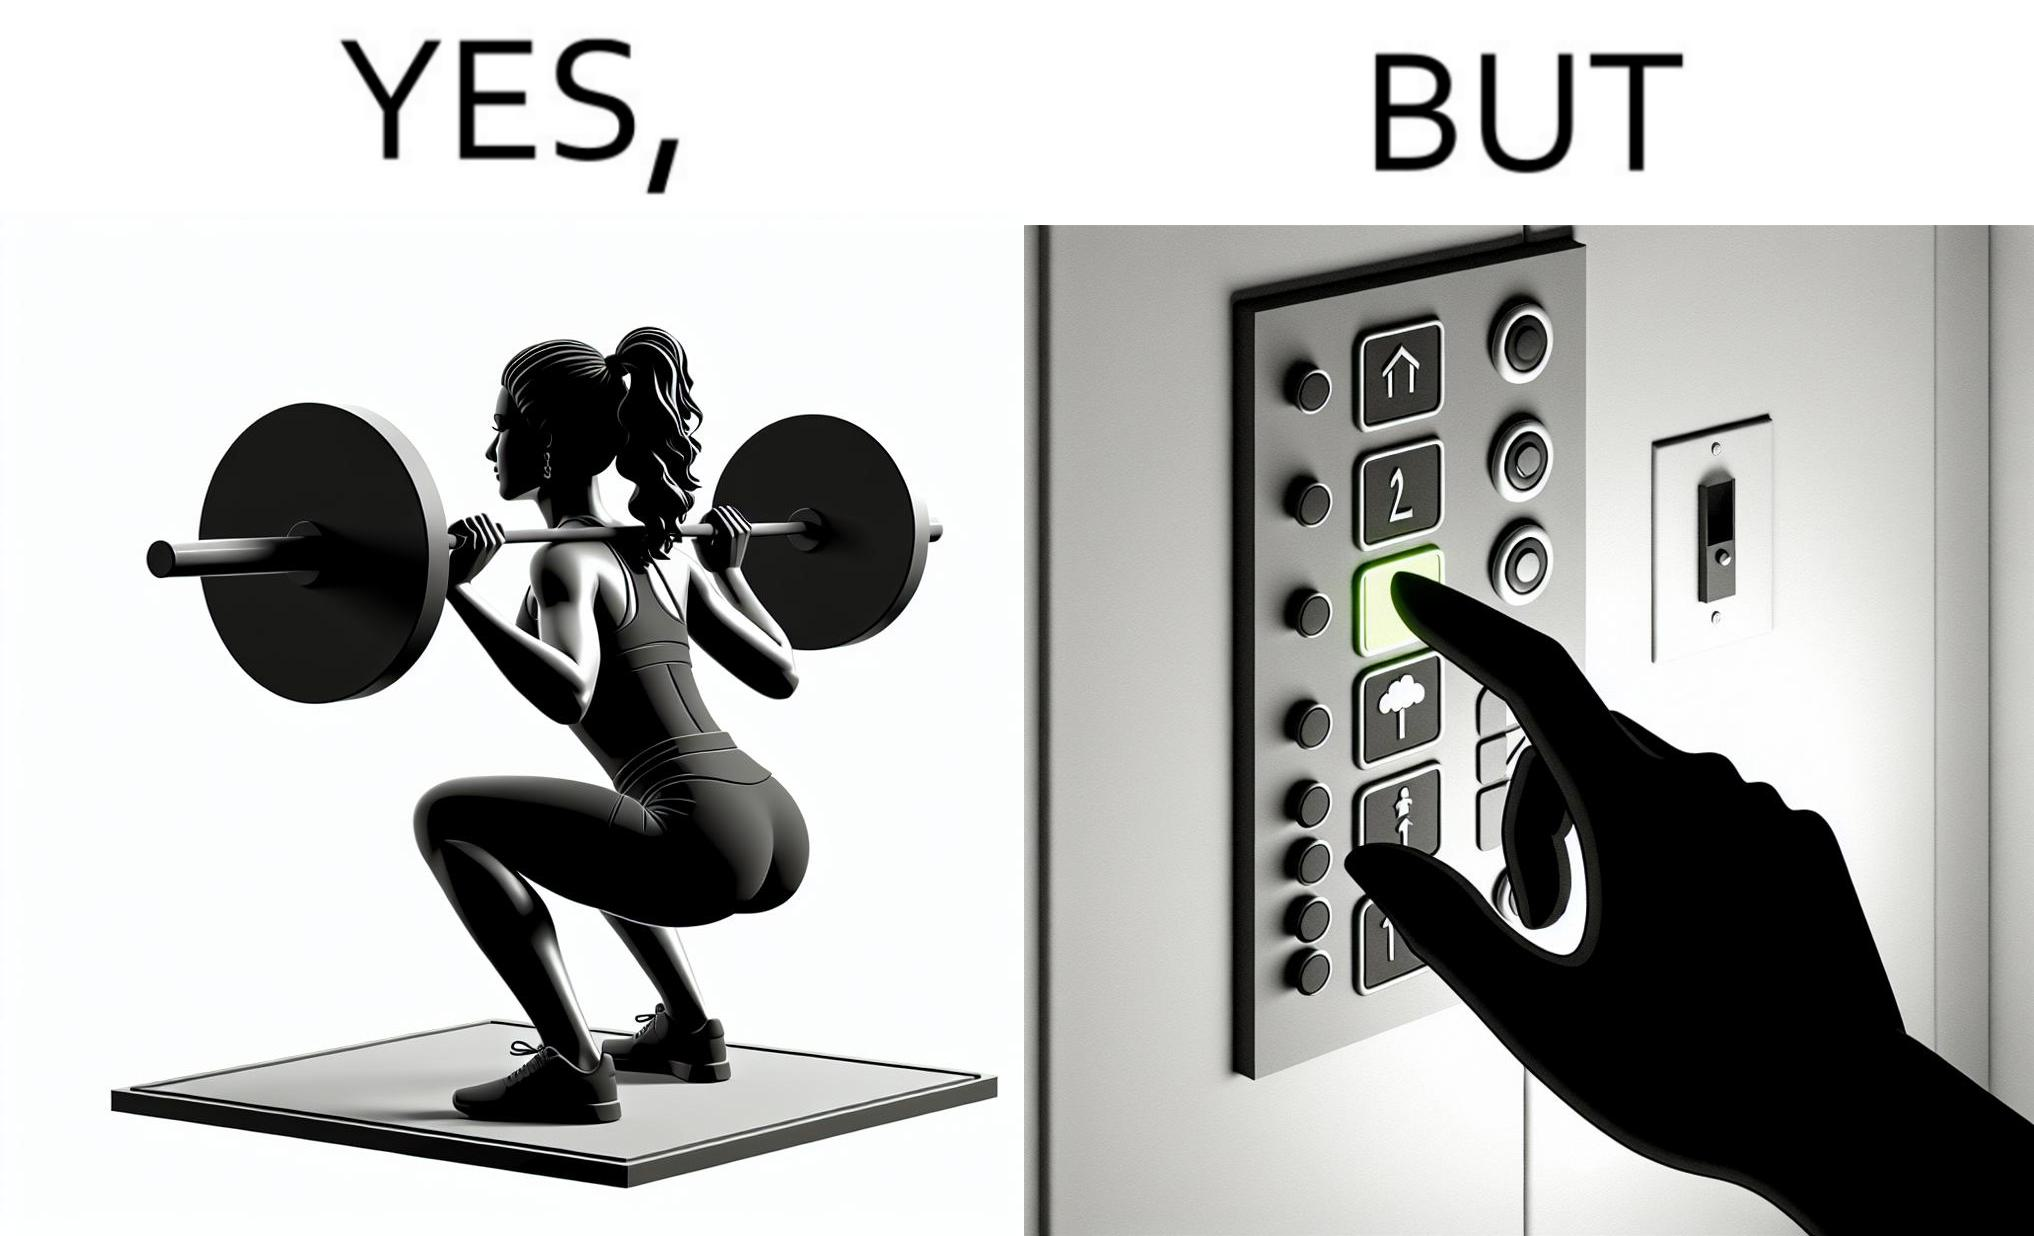What is shown in the left half versus the right half of this image? In the left part of the image: The image shows a women exercising with a bar bell in a gym. She is wearing a sport outfit. She is crouching down on one leg doing a single leg squat with a bar bell. In the right part of the image: The image shows the control panel inside of an elevator. The indicator for the first floor is green which means the button for the first floor was pressed. A hand is about to press the button for the second floor. 